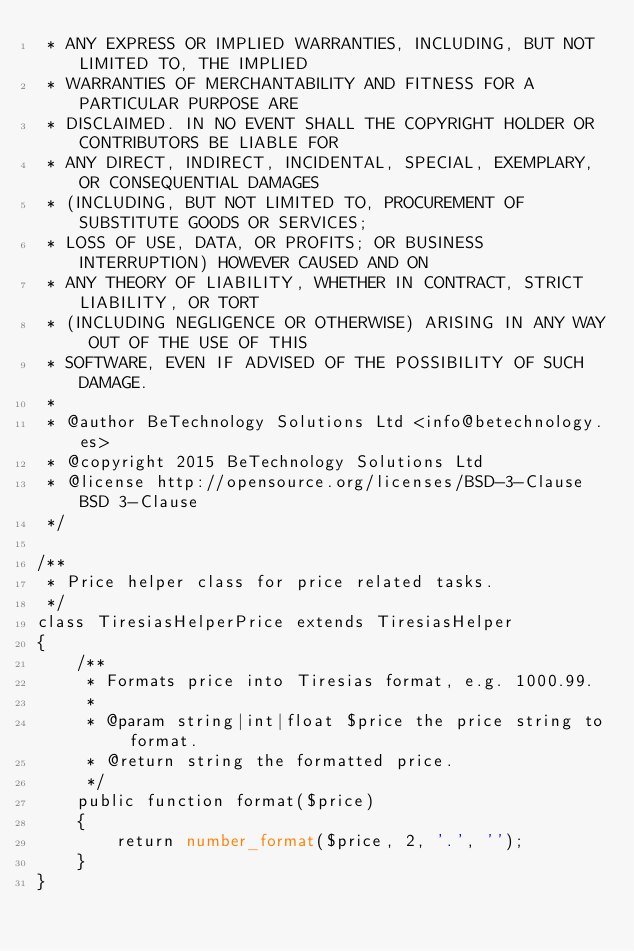Convert code to text. <code><loc_0><loc_0><loc_500><loc_500><_PHP_> * ANY EXPRESS OR IMPLIED WARRANTIES, INCLUDING, BUT NOT LIMITED TO, THE IMPLIED
 * WARRANTIES OF MERCHANTABILITY AND FITNESS FOR A PARTICULAR PURPOSE ARE
 * DISCLAIMED. IN NO EVENT SHALL THE COPYRIGHT HOLDER OR CONTRIBUTORS BE LIABLE FOR
 * ANY DIRECT, INDIRECT, INCIDENTAL, SPECIAL, EXEMPLARY, OR CONSEQUENTIAL DAMAGES
 * (INCLUDING, BUT NOT LIMITED TO, PROCUREMENT OF SUBSTITUTE GOODS OR SERVICES;
 * LOSS OF USE, DATA, OR PROFITS; OR BUSINESS INTERRUPTION) HOWEVER CAUSED AND ON
 * ANY THEORY OF LIABILITY, WHETHER IN CONTRACT, STRICT LIABILITY, OR TORT
 * (INCLUDING NEGLIGENCE OR OTHERWISE) ARISING IN ANY WAY OUT OF THE USE OF THIS
 * SOFTWARE, EVEN IF ADVISED OF THE POSSIBILITY OF SUCH DAMAGE.
 *
 * @author BeTechnology Solutions Ltd <info@betechnology.es>
 * @copyright 2015 BeTechnology Solutions Ltd
 * @license http://opensource.org/licenses/BSD-3-Clause BSD 3-Clause
 */

/**
 * Price helper class for price related tasks.
 */
class TiresiasHelperPrice extends TiresiasHelper
{
    /**
     * Formats price into Tiresias format, e.g. 1000.99.
     *
     * @param string|int|float $price the price string to format.
     * @return string the formatted price.
     */
    public function format($price)
    {
        return number_format($price, 2, '.', '');
    }
}
</code> 